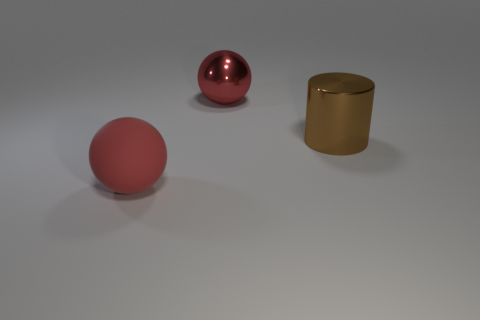How would you contrast the textures of the objects shown? The red sphere has a high-gloss finish that reflects light smoothly, suggesting a slick texture. The gold cylinder has a satin-like finish with gentle reflections, implying a less glossy texture. The brown cube, while not detailed, appears to have a matte finish with virtually no reflection, indicating a coarser texture compared to the other objects.  Given the shadows and reflections, what can we infer about the surface the objects are on? Based on the clear but muted reflections and soft shadows, it seems the objects are resting on a semi-glossy surface, which is not highly reflective, suggesting a level of roughness or texture that diffuses the reflections of the objects and the light, potentially similar to frosted glass or a polished concrete. 